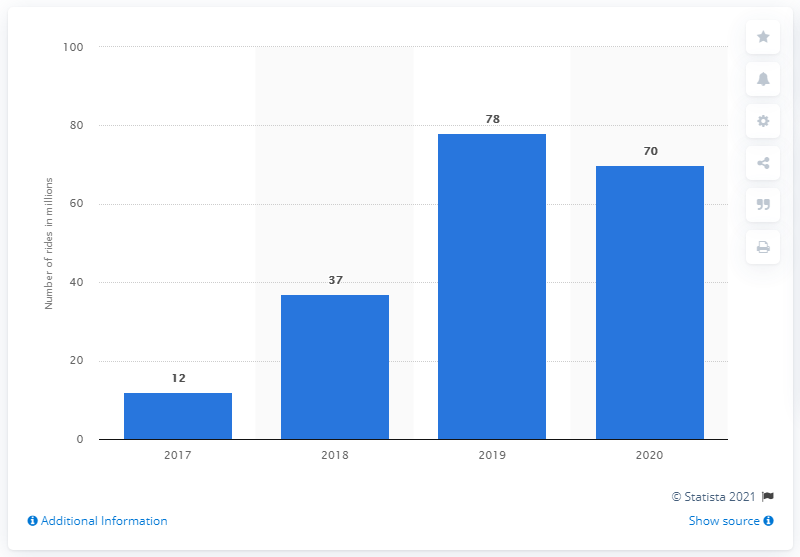Give some essential details in this illustration. In 2020, the market for car sharing was projected to be approximately 70... In 2019, the maximum number of car sharing rides was 78. In 2017, the number of car sharing rides was 12. 